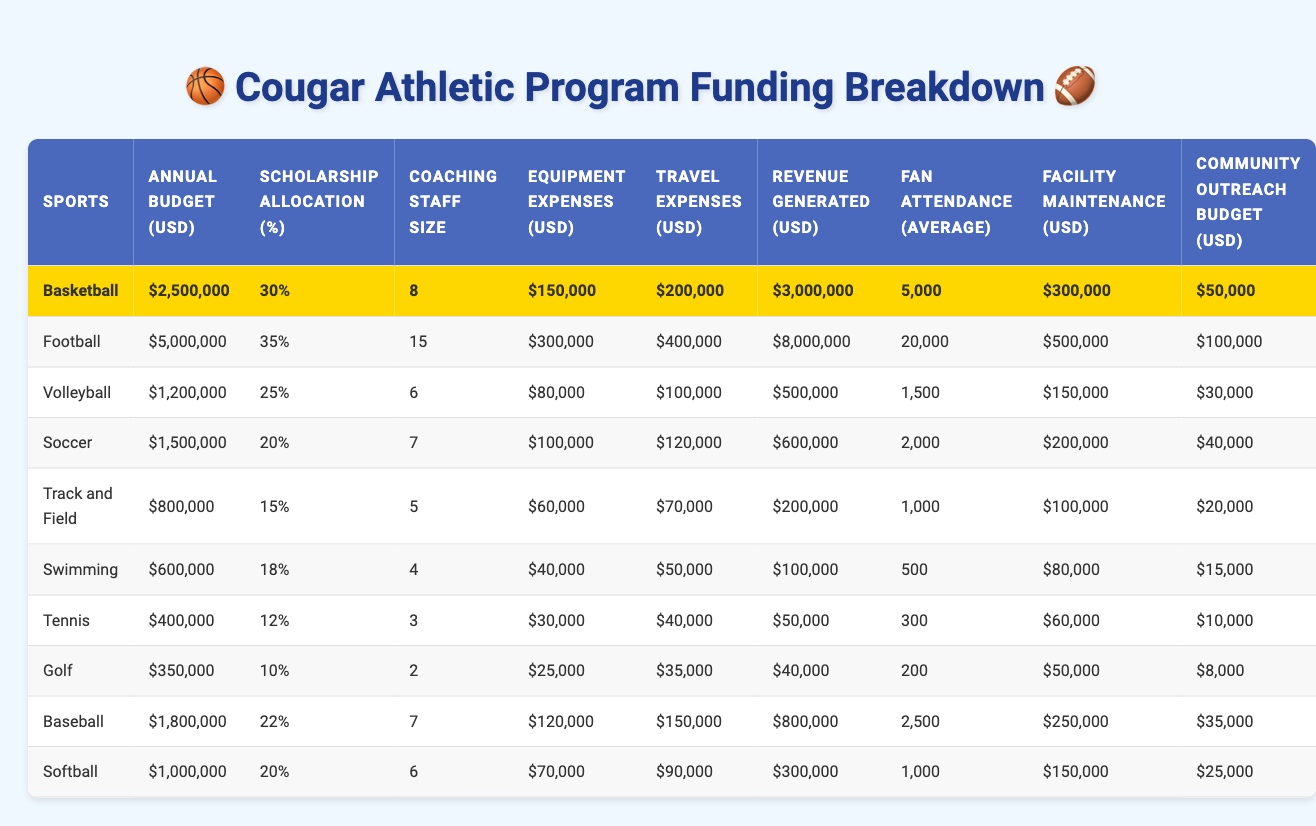What is the annual budget for the Football program? The table lists the annual budgets for each sport, and for the Football program, it shows an amount of $5,000,000.
Answer: $5,000,000 Which sport has the highest scholarship allocation percentage? By reviewing the table, the Football program has the highest scholarship allocation at 35%.
Answer: Football How much revenue does the Basketball program generate? The revenue generated by the Basketball program is listed in the table as $3,000,000.
Answer: $3,000,000 What are the equipment expenses for the Tennis program? The table indicates that the equipment expenses for the Tennis program amount to $30,000.
Answer: $30,000 Which sport has the lowest fan attendance on average? By examining the averages listed in the table, Swimming has the lowest average fan attendance of 500.
Answer: 500 What is the total annual budget for all sports combined? To find the total budget, I sum up all the annual budgets: $2,500,000 (Basketball) + $5,000,000 (Football) + $1,200,000 (Volleyball) + $1,500,000 (Soccer) + $800,000 (Track and Field) + $600,000 (Swimming) + $400,000 (Tennis) + $350,000 (Golf) + $1,800,000 (Baseball) + $1,000,000 (Softball) = $13,250,000.
Answer: $13,250,000 Is the scholarship allocation for Swimming more than 20%? The scholarship allocation for Swimming is 18%, which is less than 20%, so the answer is no.
Answer: No Which sport has the highest coaching staff size, and how many coaches are there? The Football program has the highest coaching staff size with 15 coaches, as shown in the coaching staff size column.
Answer: 15 coaches (Football) If we consider only the sports with an annual budget over $1,000,000, what is the average facility maintenance cost? The sports with budgets over $1,000,000 are Basketball, Football, Volleyball, Soccer, and Baseball, with maintenance costs of $300,000, $500,000, $150,000, $200,000, and $250,000 respectively. To calculate: (300,000 + 500,000 + 150,000 + 200,000 + 250,000) = 1,400,000, divided by 5 yields an average of $280,000.
Answer: $280,000 What percentage of the annual budget for Soccer is allocated to community outreach? The table shows the annual budget for Soccer is $1,500,000 and the community outreach budget is $40,000. To find the percentage: (40,000 / 1,500,000) * 100 = approximately 2.67%.
Answer: 2.67% Does Track and Field generate more revenue than Swimming? The revenue for Track and Field is $200,000, and for Swimming, it is $100,000. Since $200,000 is greater than $100,000, the statement is true.
Answer: Yes 